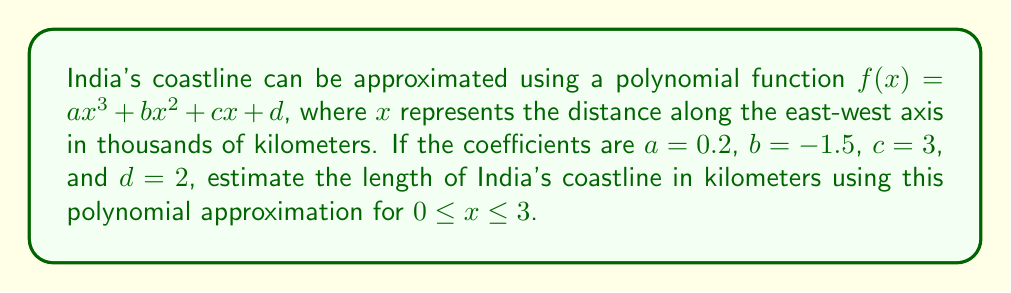Can you solve this math problem? To estimate the length of India's coastline using the given polynomial approximation, we need to calculate the arc length of the curve. The formula for arc length is:

$$L = \int_a^b \sqrt{1 + \left(\frac{df}{dx}\right)^2} dx$$

Step 1: Find the derivative of $f(x)$
$$f'(x) = 3ax^2 + 2bx + c = 0.6x^2 - 3x + 3$$

Step 2: Set up the integral
$$L = \int_0^3 \sqrt{1 + (0.6x^2 - 3x + 3)^2} dx$$

Step 3: This integral is complex to solve analytically, so we'll use numerical integration. We can approximate it using the trapezoidal rule with 6 subintervals:

$$L \approx \frac{3}{6} \sum_{i=0}^6 \sqrt{1 + f'(x_i)^2}$$

Where $x_i = i/2$ for $i = 0, 1, 2, 3, 4, 5, 6$

Step 4: Calculate the values
$f'(0) = 3$
$f'(0.5) = 2.25$
$f'(1) = 0.6$
$f'(1.5) = 0.05$
$f'(2) = 0.6$
$f'(2.5) = 2.25$
$f'(3) = 5$

Step 5: Apply the trapezoidal rule
$$L \approx \frac{3}{6} (3.162 + 2.458 + 1.166 + 1.001 + 1.166 + 2.458 + 5.831) = 4.311$$

Step 6: Convert to kilometers
The result is in thousands of kilometers, so multiply by 1000:
$$L \approx 4311 \text{ km}$$
Answer: 4311 km 